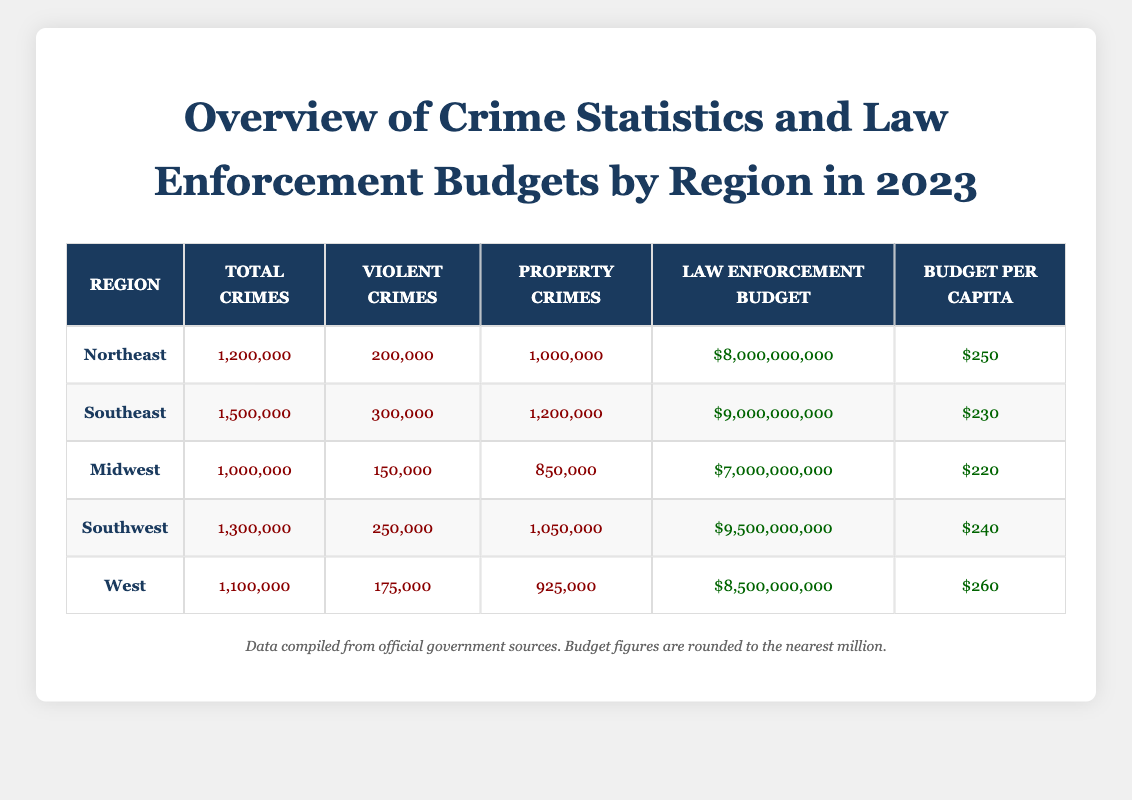What is the total number of violent crimes in the Southeast region? According to the table, the number of violent crimes in the Southeast region is explicitly listed as 300,000.
Answer: 300,000 Which region has the highest law enforcement budget? By comparing the 'Law Enforcement Budget' column, the Southwest region has the highest budget at $9,500,000,000.
Answer: Southwest What percentage of total crimes in the Midwest are violent crimes? The total number of crimes in the Midwest is 1,000,000, with violent crimes at 150,000. To find the percentage, calculate (150,000 / 1,000,000) * 100, which equals 15%.
Answer: 15% Is the law enforcement budget per capita higher in the West than in the Northeast? By comparing the budget per capita values, the West has a budget of $260 while the Northeast has $250. Thus, the West has a higher budget per capita.
Answer: Yes What is the difference in total crimes between the Northeast and the Southeast? The Northeast has 1,200,000 total crimes, and the Southeast has 1,500,000. To find the difference, subtract the Northeast total from the Southeast total: 1,500,000 - 1,200,000 = 300,000.
Answer: 300,000 What is the average law enforcement budget across all regions? To find the average budget, sum all the law enforcement budgets ($8,000,000,000 + $9,000,000,000 + $7,000,000,000 + $9,500,000,000 + $8,500,000,000 = $42,000,000,000), then divide by the number of regions (5). The average budget is $42,000,000,000 / 5 = $8,400,000,000.
Answer: $8,400,000,000 Does the Southwest region have more property crimes than the Northeast? In the Southwest region, there are 1,050,000 property crimes, while in the Northeast there are 1,000,000. Since 1,050,000 is greater than 1,000,000, the statement is true.
Answer: Yes What region has the lowest budget per capita? After inspecting the budget per capita column, the Midwest shows the lowest figure at $220.
Answer: Midwest What is the combined total of violent crimes from the Northeast and Midwest regions? The Northeast has 200,000 violent crimes and the Midwest has 150,000. Adding these together gives: 200,000 + 150,000 = 350,000.
Answer: 350,000 